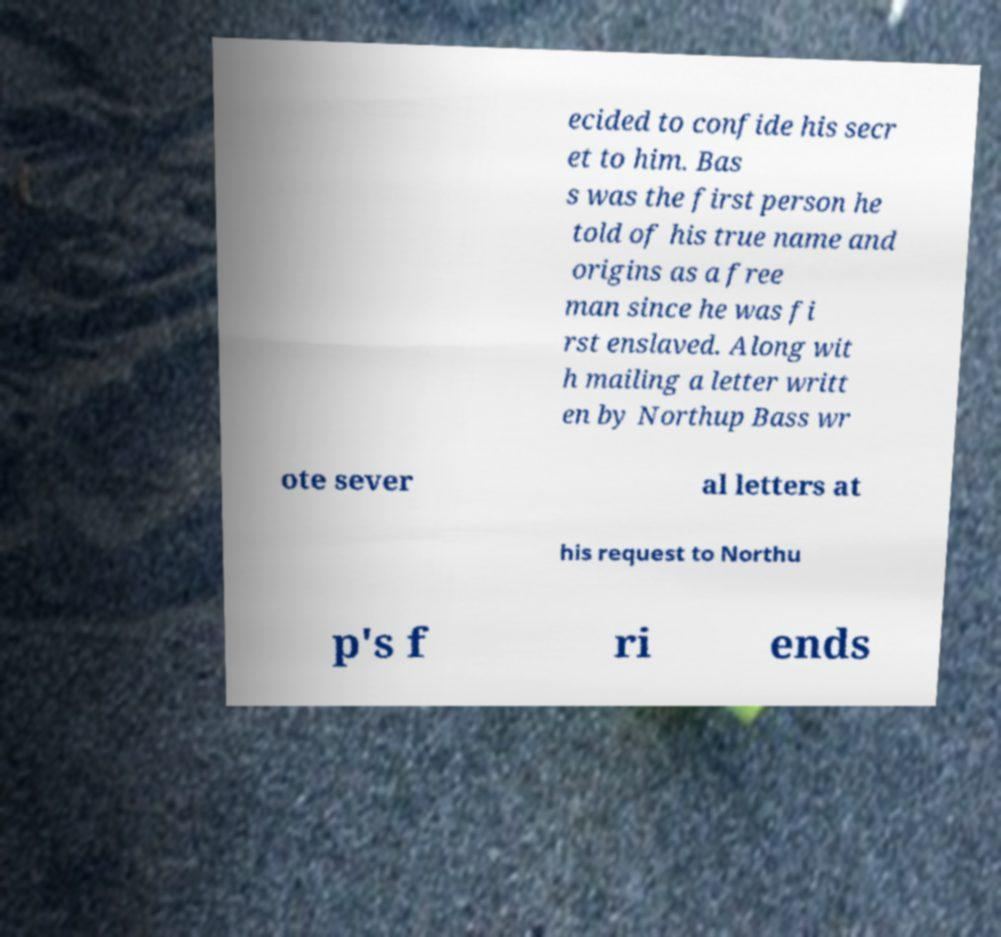Please identify and transcribe the text found in this image. ecided to confide his secr et to him. Bas s was the first person he told of his true name and origins as a free man since he was fi rst enslaved. Along wit h mailing a letter writt en by Northup Bass wr ote sever al letters at his request to Northu p's f ri ends 